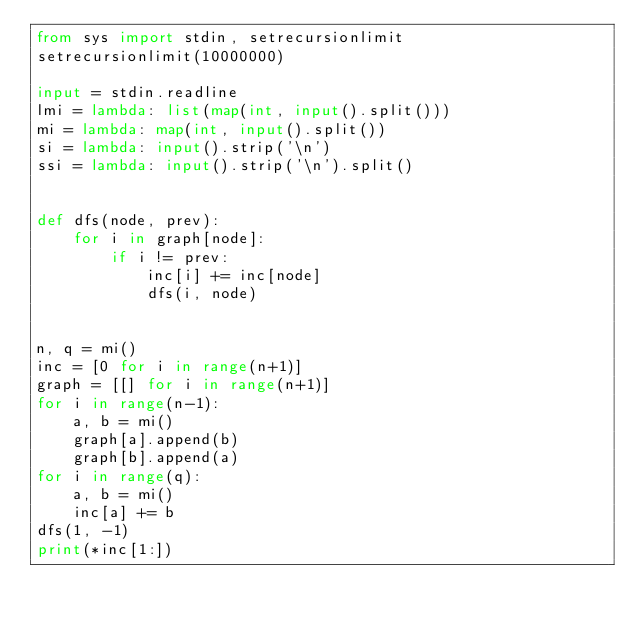Convert code to text. <code><loc_0><loc_0><loc_500><loc_500><_Python_>from sys import stdin, setrecursionlimit
setrecursionlimit(10000000)

input = stdin.readline
lmi = lambda: list(map(int, input().split()))
mi = lambda: map(int, input().split())
si = lambda: input().strip('\n')
ssi = lambda: input().strip('\n').split()


def dfs(node, prev):
    for i in graph[node]:
        if i != prev:
            inc[i] += inc[node]
            dfs(i, node)


n, q = mi()
inc = [0 for i in range(n+1)]
graph = [[] for i in range(n+1)]
for i in range(n-1):
    a, b = mi()
    graph[a].append(b)
    graph[b].append(a)
for i in range(q):
    a, b = mi()
    inc[a] += b
dfs(1, -1)
print(*inc[1:])</code> 